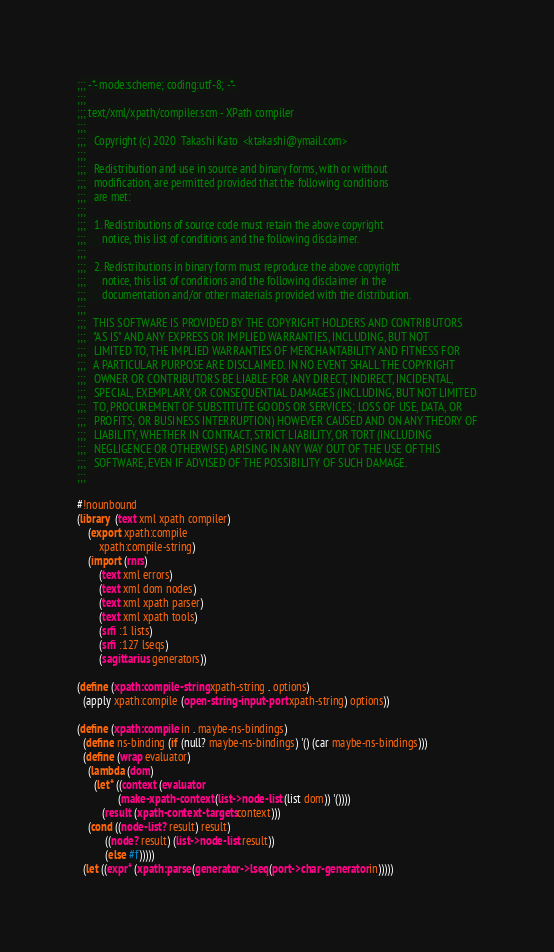Convert code to text. <code><loc_0><loc_0><loc_500><loc_500><_Scheme_>;;; -*- mode:scheme; coding:utf-8; -*-
;;;
;;; text/xml/xpath/compiler.scm - XPath compiler
;;;
;;;   Copyright (c) 2020  Takashi Kato  <ktakashi@ymail.com>
;;;
;;;   Redistribution and use in source and binary forms, with or without
;;;   modification, are permitted provided that the following conditions
;;;   are met:
;;;
;;;   1. Redistributions of source code must retain the above copyright
;;;      notice, this list of conditions and the following disclaimer.
;;;
;;;   2. Redistributions in binary form must reproduce the above copyright
;;;      notice, this list of conditions and the following disclaimer in the
;;;      documentation and/or other materials provided with the distribution.
;;;
;;;   THIS SOFTWARE IS PROVIDED BY THE COPYRIGHT HOLDERS AND CONTRIBUTORS
;;;   "AS IS" AND ANY EXPRESS OR IMPLIED WARRANTIES, INCLUDING, BUT NOT
;;;   LIMITED TO, THE IMPLIED WARRANTIES OF MERCHANTABILITY AND FITNESS FOR
;;;   A PARTICULAR PURPOSE ARE DISCLAIMED. IN NO EVENT SHALL THE COPYRIGHT
;;;   OWNER OR CONTRIBUTORS BE LIABLE FOR ANY DIRECT, INDIRECT, INCIDENTAL,
;;;   SPECIAL, EXEMPLARY, OR CONSEQUENTIAL DAMAGES (INCLUDING, BUT NOT LIMITED
;;;   TO, PROCUREMENT OF SUBSTITUTE GOODS OR SERVICES; LOSS OF USE, DATA, OR
;;;   PROFITS; OR BUSINESS INTERRUPTION) HOWEVER CAUSED AND ON ANY THEORY OF
;;;   LIABILITY, WHETHER IN CONTRACT, STRICT LIABILITY, OR TORT (INCLUDING
;;;   NEGLIGENCE OR OTHERWISE) ARISING IN ANY WAY OUT OF THE USE OF THIS
;;;   SOFTWARE, EVEN IF ADVISED OF THE POSSIBILITY OF SUCH DAMAGE.
;;;

#!nounbound
(library  (text xml xpath compiler)
    (export xpath:compile
	    xpath:compile-string)
    (import (rnrs)
	    (text xml errors)
	    (text xml dom nodes)
	    (text xml xpath parser)
	    (text xml xpath tools)
	    (srfi :1 lists)
	    (srfi :127 lseqs)
	    (sagittarius generators))

(define (xpath:compile-string xpath-string . options)
  (apply xpath:compile (open-string-input-port xpath-string) options))

(define (xpath:compile in . maybe-ns-bindings)
  (define ns-binding (if (null? maybe-ns-bindings) '() (car maybe-ns-bindings)))
  (define (wrap evaluator)
    (lambda (dom)
      (let* ((context (evaluator
		       (make-xpath-context (list->node-list (list dom)) '())))
	     (result (xpath-context-targets context)))
	(cond ((node-list? result) result)
	      ((node? result) (list->node-list result))
	      (else #f)))))
  (let ((expr* (xpath:parse (generator->lseq (port->char-generator in)))))</code> 